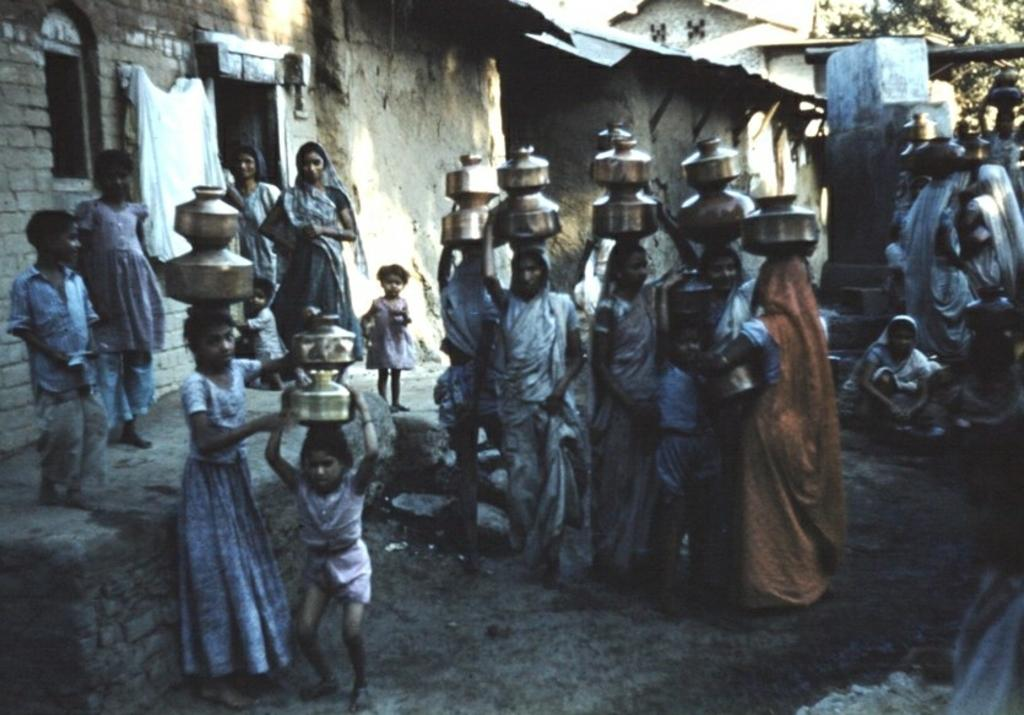How many people are present in the image? There are multiple people in the image. What are the people doing in the image? Most of the people are carrying utensils on their heads. What can be seen in the background of the image? There are buildings and a tree visible in the background of the image. What month is it in the image? The month cannot be determined from the image, as there is no information about the time of year. Can you see any toys in the image? There are no toys visible in the image. 